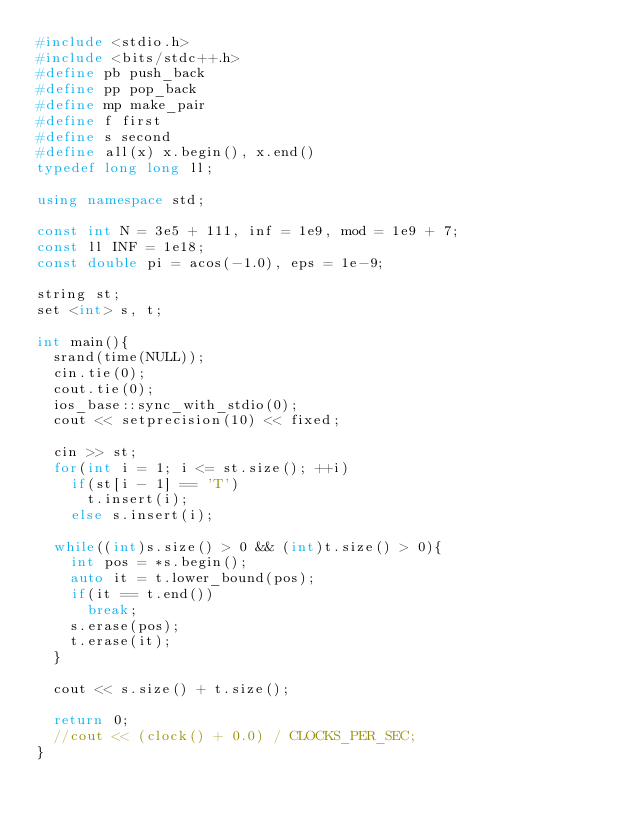Convert code to text. <code><loc_0><loc_0><loc_500><loc_500><_C++_>#include <stdio.h>
#include <bits/stdc++.h>
#define pb push_back
#define pp pop_back
#define mp make_pair
#define f first
#define s second
#define all(x) x.begin(), x.end()
typedef long long ll;

using namespace std;

const int N = 3e5 + 111, inf = 1e9, mod = 1e9 + 7;
const ll INF = 1e18;
const double pi = acos(-1.0), eps = 1e-9;

string st;
set <int> s, t;

int main(){
	srand(time(NULL));
	cin.tie(0);
	cout.tie(0);
	ios_base::sync_with_stdio(0);
	cout << setprecision(10) << fixed;

	cin >> st;
	for(int i = 1; i <= st.size(); ++i) 
		if(st[i - 1] == 'T')
			t.insert(i);
		else s.insert(i);

	while((int)s.size() > 0 && (int)t.size() > 0){
		int pos = *s.begin();
		auto it = t.lower_bound(pos);
		if(it == t.end())
			break;
		s.erase(pos);
		t.erase(it);
	}

	cout << s.size() + t.size();
	
	return 0;
	//cout << (clock() + 0.0) / CLOCKS_PER_SEC;
}</code> 